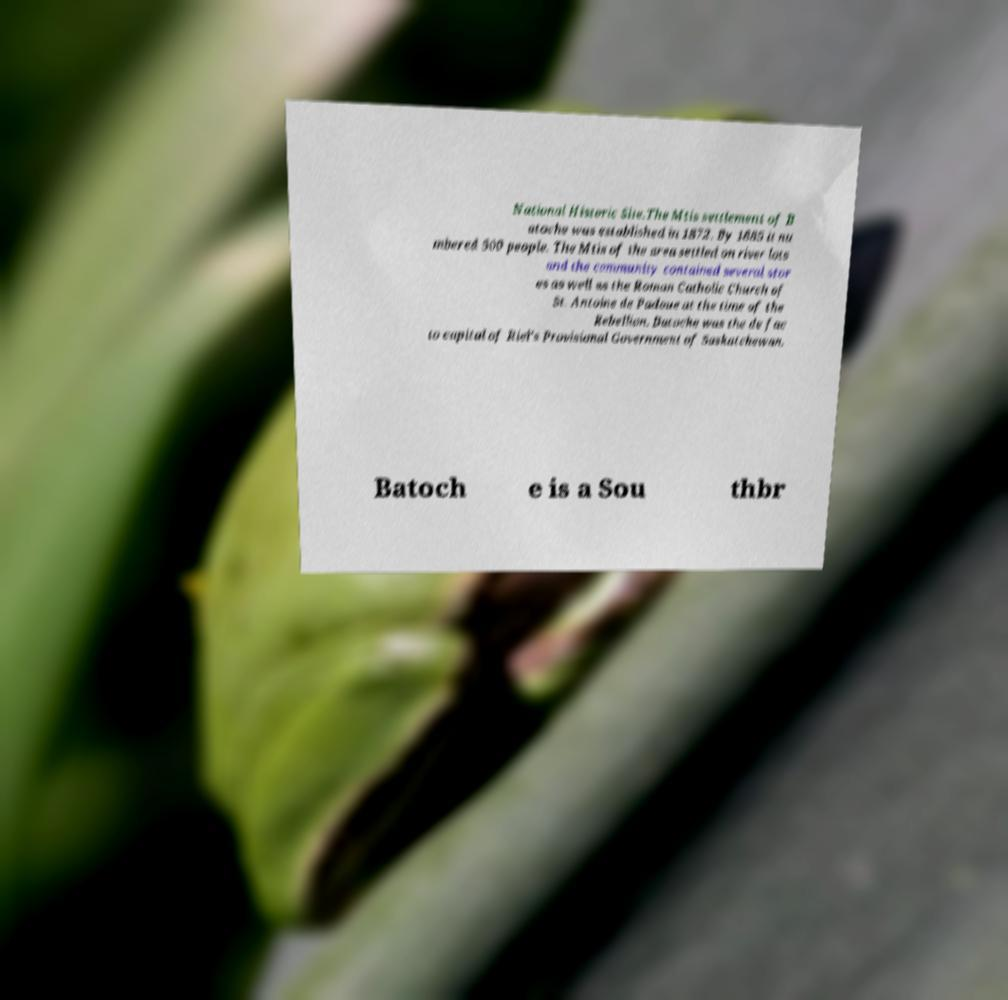Could you assist in decoding the text presented in this image and type it out clearly? National Historic Site.The Mtis settlement of B atoche was established in 1872. By 1885 it nu mbered 500 people. The Mtis of the area settled on river lots and the community contained several stor es as well as the Roman Catholic Church of St. Antoine de Padoue at the time of the Rebellion. Batoche was the de fac to capital of Riel's Provisional Government of Saskatchewan. Batoch e is a Sou thbr 